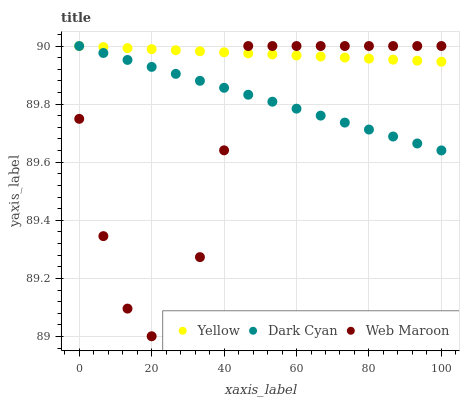Does Web Maroon have the minimum area under the curve?
Answer yes or no. Yes. Does Yellow have the maximum area under the curve?
Answer yes or no. Yes. Does Yellow have the minimum area under the curve?
Answer yes or no. No. Does Web Maroon have the maximum area under the curve?
Answer yes or no. No. Is Yellow the smoothest?
Answer yes or no. Yes. Is Web Maroon the roughest?
Answer yes or no. Yes. Is Web Maroon the smoothest?
Answer yes or no. No. Is Yellow the roughest?
Answer yes or no. No. Does Web Maroon have the lowest value?
Answer yes or no. Yes. Does Yellow have the lowest value?
Answer yes or no. No. Does Yellow have the highest value?
Answer yes or no. Yes. Does Dark Cyan intersect Yellow?
Answer yes or no. Yes. Is Dark Cyan less than Yellow?
Answer yes or no. No. Is Dark Cyan greater than Yellow?
Answer yes or no. No. 